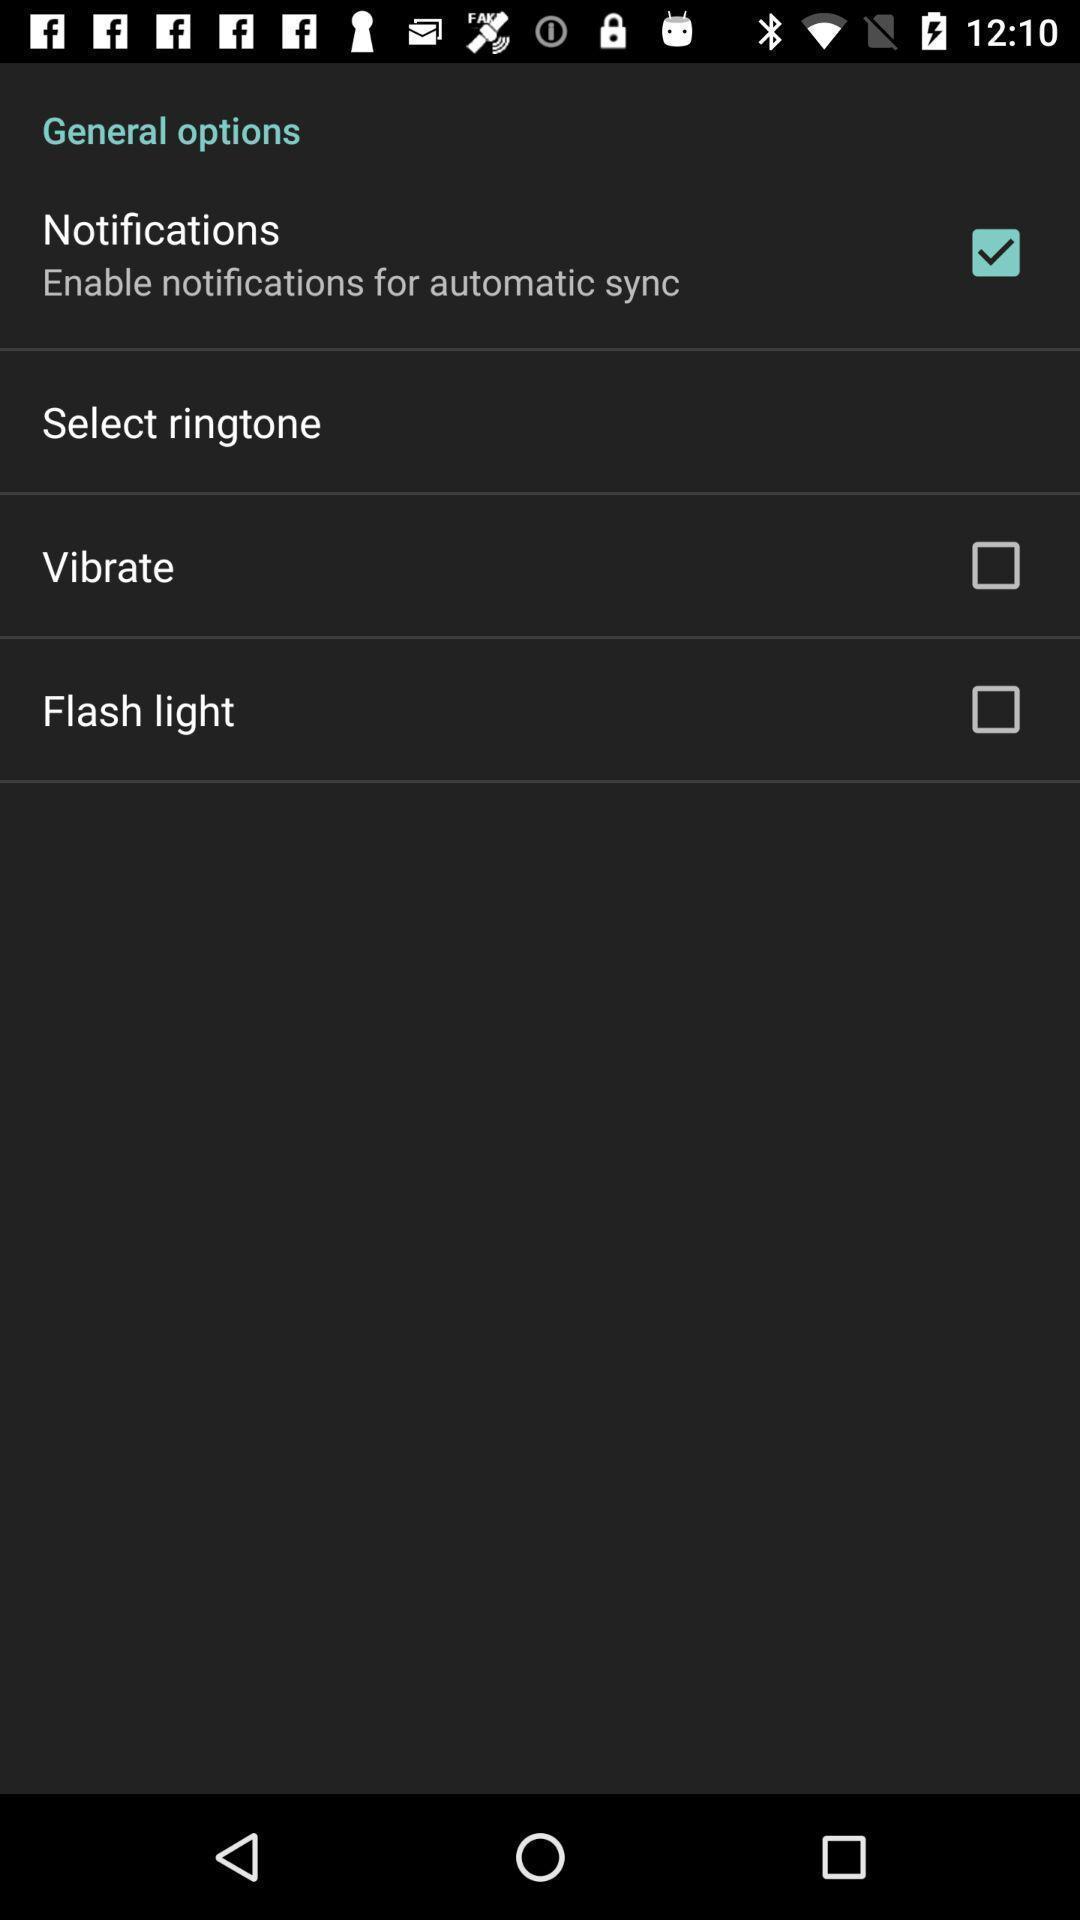Describe the content in this image. Screen displaying multiple setting options. 